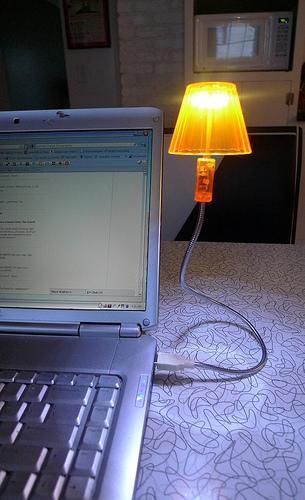How many laptops are there?
Give a very brief answer. 1. 